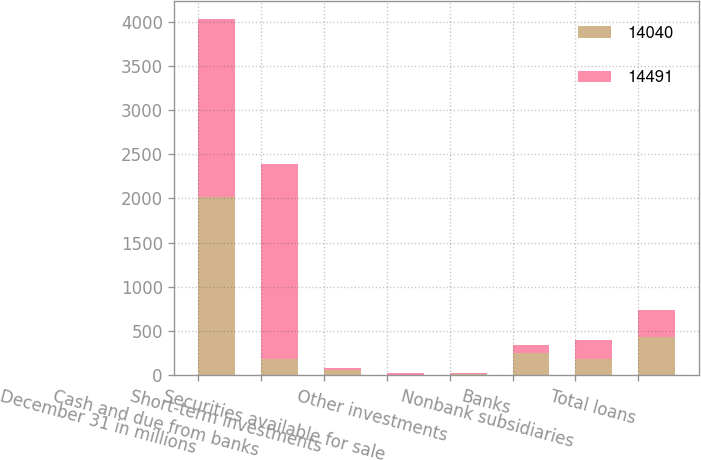Convert chart. <chart><loc_0><loc_0><loc_500><loc_500><stacked_bar_chart><ecel><fcel>December 31 in millions<fcel>Cash and due from banks<fcel>Short-term investments<fcel>Securities available for sale<fcel>Other investments<fcel>Banks<fcel>Nonbank subsidiaries<fcel>Total loans<nl><fcel>14040<fcel>2015<fcel>187<fcel>58<fcel>10<fcel>14<fcel>250<fcel>187<fcel>437<nl><fcel>14491<fcel>2014<fcel>2207<fcel>31<fcel>22<fcel>15<fcel>90<fcel>211<fcel>301<nl></chart> 